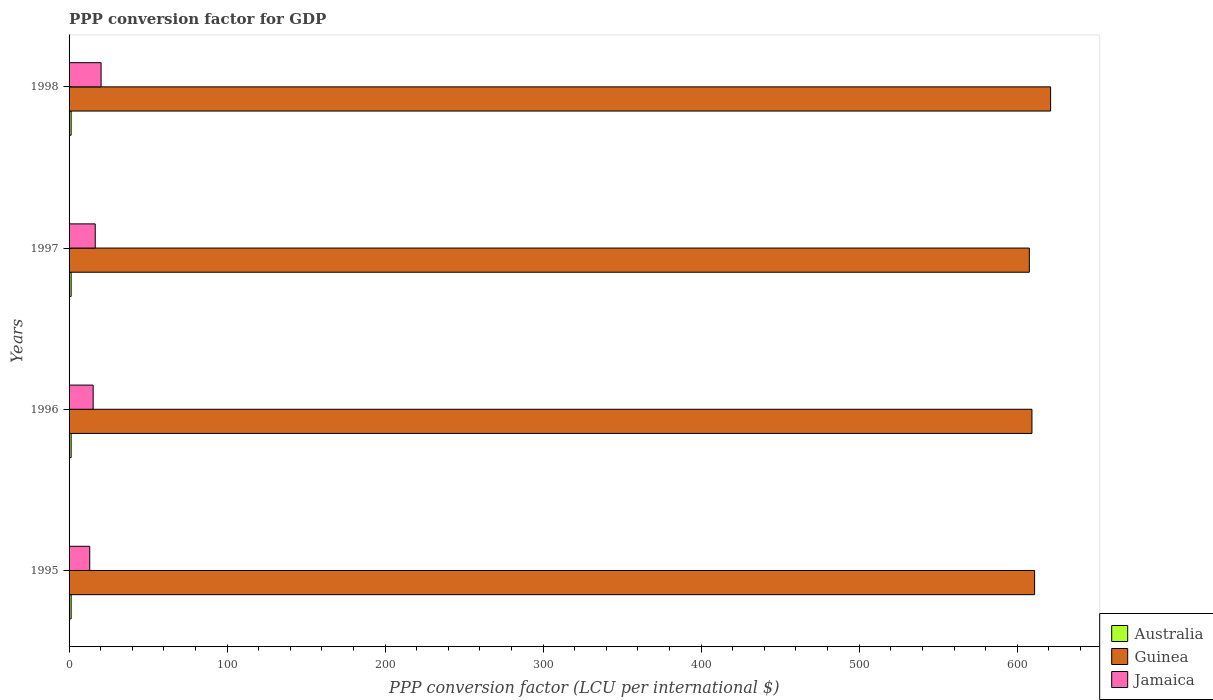How many groups of bars are there?
Provide a short and direct response. 4. Are the number of bars per tick equal to the number of legend labels?
Your answer should be compact. Yes. Are the number of bars on each tick of the Y-axis equal?
Provide a short and direct response. Yes. How many bars are there on the 1st tick from the top?
Provide a short and direct response. 3. How many bars are there on the 3rd tick from the bottom?
Your response must be concise. 3. What is the label of the 4th group of bars from the top?
Your answer should be compact. 1995. In how many cases, is the number of bars for a given year not equal to the number of legend labels?
Your response must be concise. 0. What is the PPP conversion factor for GDP in Guinea in 1997?
Your response must be concise. 607.68. Across all years, what is the maximum PPP conversion factor for GDP in Guinea?
Your answer should be compact. 621.14. Across all years, what is the minimum PPP conversion factor for GDP in Guinea?
Keep it short and to the point. 607.68. What is the total PPP conversion factor for GDP in Jamaica in the graph?
Provide a succinct answer. 65.15. What is the difference between the PPP conversion factor for GDP in Guinea in 1995 and that in 1997?
Your answer should be compact. 3.34. What is the difference between the PPP conversion factor for GDP in Australia in 1996 and the PPP conversion factor for GDP in Jamaica in 1995?
Offer a terse response. -11.77. What is the average PPP conversion factor for GDP in Jamaica per year?
Keep it short and to the point. 16.29. In the year 1998, what is the difference between the PPP conversion factor for GDP in Guinea and PPP conversion factor for GDP in Australia?
Keep it short and to the point. 619.84. What is the ratio of the PPP conversion factor for GDP in Australia in 1995 to that in 1996?
Provide a succinct answer. 1. Is the PPP conversion factor for GDP in Jamaica in 1995 less than that in 1997?
Make the answer very short. Yes. Is the difference between the PPP conversion factor for GDP in Guinea in 1995 and 1996 greater than the difference between the PPP conversion factor for GDP in Australia in 1995 and 1996?
Make the answer very short. Yes. What is the difference between the highest and the second highest PPP conversion factor for GDP in Australia?
Make the answer very short. 0. What is the difference between the highest and the lowest PPP conversion factor for GDP in Australia?
Offer a terse response. 0.01. What does the 1st bar from the top in 1995 represents?
Provide a succinct answer. Jamaica. What does the 2nd bar from the bottom in 1996 represents?
Provide a succinct answer. Guinea. Is it the case that in every year, the sum of the PPP conversion factor for GDP in Guinea and PPP conversion factor for GDP in Australia is greater than the PPP conversion factor for GDP in Jamaica?
Your answer should be very brief. Yes. How many bars are there?
Give a very brief answer. 12. How many years are there in the graph?
Keep it short and to the point. 4. What is the difference between two consecutive major ticks on the X-axis?
Provide a succinct answer. 100. Are the values on the major ticks of X-axis written in scientific E-notation?
Offer a very short reply. No. Where does the legend appear in the graph?
Keep it short and to the point. Bottom right. How are the legend labels stacked?
Your response must be concise. Vertical. What is the title of the graph?
Ensure brevity in your answer.  PPP conversion factor for GDP. What is the label or title of the X-axis?
Offer a very short reply. PPP conversion factor (LCU per international $). What is the label or title of the Y-axis?
Offer a very short reply. Years. What is the PPP conversion factor (LCU per international $) in Australia in 1995?
Your answer should be compact. 1.31. What is the PPP conversion factor (LCU per international $) of Guinea in 1995?
Ensure brevity in your answer.  611.01. What is the PPP conversion factor (LCU per international $) of Jamaica in 1995?
Give a very brief answer. 13.08. What is the PPP conversion factor (LCU per international $) in Australia in 1996?
Keep it short and to the point. 1.31. What is the PPP conversion factor (LCU per international $) of Guinea in 1996?
Your answer should be compact. 609.34. What is the PPP conversion factor (LCU per international $) in Jamaica in 1996?
Keep it short and to the point. 15.25. What is the PPP conversion factor (LCU per international $) in Australia in 1997?
Keep it short and to the point. 1.31. What is the PPP conversion factor (LCU per international $) in Guinea in 1997?
Provide a short and direct response. 607.68. What is the PPP conversion factor (LCU per international $) of Jamaica in 1997?
Give a very brief answer. 16.56. What is the PPP conversion factor (LCU per international $) of Australia in 1998?
Provide a short and direct response. 1.3. What is the PPP conversion factor (LCU per international $) of Guinea in 1998?
Provide a short and direct response. 621.14. What is the PPP conversion factor (LCU per international $) of Jamaica in 1998?
Ensure brevity in your answer.  20.26. Across all years, what is the maximum PPP conversion factor (LCU per international $) of Australia?
Offer a very short reply. 1.31. Across all years, what is the maximum PPP conversion factor (LCU per international $) of Guinea?
Make the answer very short. 621.14. Across all years, what is the maximum PPP conversion factor (LCU per international $) of Jamaica?
Provide a short and direct response. 20.26. Across all years, what is the minimum PPP conversion factor (LCU per international $) in Australia?
Keep it short and to the point. 1.3. Across all years, what is the minimum PPP conversion factor (LCU per international $) of Guinea?
Ensure brevity in your answer.  607.68. Across all years, what is the minimum PPP conversion factor (LCU per international $) of Jamaica?
Provide a short and direct response. 13.08. What is the total PPP conversion factor (LCU per international $) in Australia in the graph?
Make the answer very short. 5.23. What is the total PPP conversion factor (LCU per international $) of Guinea in the graph?
Offer a terse response. 2449.16. What is the total PPP conversion factor (LCU per international $) of Jamaica in the graph?
Offer a very short reply. 65.15. What is the difference between the PPP conversion factor (LCU per international $) in Australia in 1995 and that in 1996?
Provide a short and direct response. -0. What is the difference between the PPP conversion factor (LCU per international $) of Guinea in 1995 and that in 1996?
Your answer should be very brief. 1.68. What is the difference between the PPP conversion factor (LCU per international $) in Jamaica in 1995 and that in 1996?
Your answer should be very brief. -2.17. What is the difference between the PPP conversion factor (LCU per international $) in Australia in 1995 and that in 1997?
Offer a terse response. -0. What is the difference between the PPP conversion factor (LCU per international $) in Guinea in 1995 and that in 1997?
Keep it short and to the point. 3.34. What is the difference between the PPP conversion factor (LCU per international $) of Jamaica in 1995 and that in 1997?
Keep it short and to the point. -3.48. What is the difference between the PPP conversion factor (LCU per international $) in Australia in 1995 and that in 1998?
Offer a very short reply. 0.01. What is the difference between the PPP conversion factor (LCU per international $) in Guinea in 1995 and that in 1998?
Your answer should be compact. -10.12. What is the difference between the PPP conversion factor (LCU per international $) in Jamaica in 1995 and that in 1998?
Give a very brief answer. -7.18. What is the difference between the PPP conversion factor (LCU per international $) of Australia in 1996 and that in 1997?
Your answer should be compact. 0. What is the difference between the PPP conversion factor (LCU per international $) of Guinea in 1996 and that in 1997?
Keep it short and to the point. 1.66. What is the difference between the PPP conversion factor (LCU per international $) in Jamaica in 1996 and that in 1997?
Provide a succinct answer. -1.31. What is the difference between the PPP conversion factor (LCU per international $) of Australia in 1996 and that in 1998?
Provide a succinct answer. 0.01. What is the difference between the PPP conversion factor (LCU per international $) of Guinea in 1996 and that in 1998?
Your answer should be very brief. -11.8. What is the difference between the PPP conversion factor (LCU per international $) in Jamaica in 1996 and that in 1998?
Your response must be concise. -5.01. What is the difference between the PPP conversion factor (LCU per international $) of Australia in 1997 and that in 1998?
Keep it short and to the point. 0.01. What is the difference between the PPP conversion factor (LCU per international $) of Guinea in 1997 and that in 1998?
Your answer should be compact. -13.46. What is the difference between the PPP conversion factor (LCU per international $) in Jamaica in 1997 and that in 1998?
Offer a very short reply. -3.7. What is the difference between the PPP conversion factor (LCU per international $) of Australia in 1995 and the PPP conversion factor (LCU per international $) of Guinea in 1996?
Offer a very short reply. -608.03. What is the difference between the PPP conversion factor (LCU per international $) of Australia in 1995 and the PPP conversion factor (LCU per international $) of Jamaica in 1996?
Offer a terse response. -13.94. What is the difference between the PPP conversion factor (LCU per international $) of Guinea in 1995 and the PPP conversion factor (LCU per international $) of Jamaica in 1996?
Offer a very short reply. 595.76. What is the difference between the PPP conversion factor (LCU per international $) in Australia in 1995 and the PPP conversion factor (LCU per international $) in Guinea in 1997?
Ensure brevity in your answer.  -606.37. What is the difference between the PPP conversion factor (LCU per international $) of Australia in 1995 and the PPP conversion factor (LCU per international $) of Jamaica in 1997?
Offer a terse response. -15.25. What is the difference between the PPP conversion factor (LCU per international $) in Guinea in 1995 and the PPP conversion factor (LCU per international $) in Jamaica in 1997?
Offer a terse response. 594.45. What is the difference between the PPP conversion factor (LCU per international $) in Australia in 1995 and the PPP conversion factor (LCU per international $) in Guinea in 1998?
Keep it short and to the point. -619.83. What is the difference between the PPP conversion factor (LCU per international $) in Australia in 1995 and the PPP conversion factor (LCU per international $) in Jamaica in 1998?
Ensure brevity in your answer.  -18.95. What is the difference between the PPP conversion factor (LCU per international $) in Guinea in 1995 and the PPP conversion factor (LCU per international $) in Jamaica in 1998?
Provide a succinct answer. 590.76. What is the difference between the PPP conversion factor (LCU per international $) of Australia in 1996 and the PPP conversion factor (LCU per international $) of Guinea in 1997?
Your answer should be compact. -606.36. What is the difference between the PPP conversion factor (LCU per international $) in Australia in 1996 and the PPP conversion factor (LCU per international $) in Jamaica in 1997?
Your answer should be very brief. -15.25. What is the difference between the PPP conversion factor (LCU per international $) in Guinea in 1996 and the PPP conversion factor (LCU per international $) in Jamaica in 1997?
Offer a terse response. 592.78. What is the difference between the PPP conversion factor (LCU per international $) in Australia in 1996 and the PPP conversion factor (LCU per international $) in Guinea in 1998?
Provide a short and direct response. -619.83. What is the difference between the PPP conversion factor (LCU per international $) of Australia in 1996 and the PPP conversion factor (LCU per international $) of Jamaica in 1998?
Offer a terse response. -18.95. What is the difference between the PPP conversion factor (LCU per international $) in Guinea in 1996 and the PPP conversion factor (LCU per international $) in Jamaica in 1998?
Provide a succinct answer. 589.08. What is the difference between the PPP conversion factor (LCU per international $) in Australia in 1997 and the PPP conversion factor (LCU per international $) in Guinea in 1998?
Provide a short and direct response. -619.83. What is the difference between the PPP conversion factor (LCU per international $) of Australia in 1997 and the PPP conversion factor (LCU per international $) of Jamaica in 1998?
Your response must be concise. -18.95. What is the difference between the PPP conversion factor (LCU per international $) in Guinea in 1997 and the PPP conversion factor (LCU per international $) in Jamaica in 1998?
Keep it short and to the point. 587.42. What is the average PPP conversion factor (LCU per international $) of Australia per year?
Your answer should be compact. 1.31. What is the average PPP conversion factor (LCU per international $) of Guinea per year?
Make the answer very short. 612.29. What is the average PPP conversion factor (LCU per international $) in Jamaica per year?
Provide a short and direct response. 16.29. In the year 1995, what is the difference between the PPP conversion factor (LCU per international $) in Australia and PPP conversion factor (LCU per international $) in Guinea?
Keep it short and to the point. -609.71. In the year 1995, what is the difference between the PPP conversion factor (LCU per international $) of Australia and PPP conversion factor (LCU per international $) of Jamaica?
Your answer should be very brief. -11.77. In the year 1995, what is the difference between the PPP conversion factor (LCU per international $) in Guinea and PPP conversion factor (LCU per international $) in Jamaica?
Your answer should be compact. 597.94. In the year 1996, what is the difference between the PPP conversion factor (LCU per international $) in Australia and PPP conversion factor (LCU per international $) in Guinea?
Provide a short and direct response. -608.02. In the year 1996, what is the difference between the PPP conversion factor (LCU per international $) of Australia and PPP conversion factor (LCU per international $) of Jamaica?
Make the answer very short. -13.94. In the year 1996, what is the difference between the PPP conversion factor (LCU per international $) of Guinea and PPP conversion factor (LCU per international $) of Jamaica?
Give a very brief answer. 594.09. In the year 1997, what is the difference between the PPP conversion factor (LCU per international $) of Australia and PPP conversion factor (LCU per international $) of Guinea?
Your answer should be very brief. -606.36. In the year 1997, what is the difference between the PPP conversion factor (LCU per international $) in Australia and PPP conversion factor (LCU per international $) in Jamaica?
Your response must be concise. -15.25. In the year 1997, what is the difference between the PPP conversion factor (LCU per international $) of Guinea and PPP conversion factor (LCU per international $) of Jamaica?
Offer a terse response. 591.12. In the year 1998, what is the difference between the PPP conversion factor (LCU per international $) of Australia and PPP conversion factor (LCU per international $) of Guinea?
Offer a terse response. -619.84. In the year 1998, what is the difference between the PPP conversion factor (LCU per international $) in Australia and PPP conversion factor (LCU per international $) in Jamaica?
Your response must be concise. -18.96. In the year 1998, what is the difference between the PPP conversion factor (LCU per international $) in Guinea and PPP conversion factor (LCU per international $) in Jamaica?
Offer a very short reply. 600.88. What is the ratio of the PPP conversion factor (LCU per international $) of Australia in 1995 to that in 1996?
Your response must be concise. 1. What is the ratio of the PPP conversion factor (LCU per international $) of Guinea in 1995 to that in 1996?
Your answer should be very brief. 1. What is the ratio of the PPP conversion factor (LCU per international $) of Jamaica in 1995 to that in 1996?
Your response must be concise. 0.86. What is the ratio of the PPP conversion factor (LCU per international $) of Guinea in 1995 to that in 1997?
Give a very brief answer. 1.01. What is the ratio of the PPP conversion factor (LCU per international $) of Jamaica in 1995 to that in 1997?
Give a very brief answer. 0.79. What is the ratio of the PPP conversion factor (LCU per international $) of Guinea in 1995 to that in 1998?
Provide a succinct answer. 0.98. What is the ratio of the PPP conversion factor (LCU per international $) of Jamaica in 1995 to that in 1998?
Provide a short and direct response. 0.65. What is the ratio of the PPP conversion factor (LCU per international $) in Guinea in 1996 to that in 1997?
Provide a succinct answer. 1. What is the ratio of the PPP conversion factor (LCU per international $) of Jamaica in 1996 to that in 1997?
Provide a succinct answer. 0.92. What is the ratio of the PPP conversion factor (LCU per international $) in Jamaica in 1996 to that in 1998?
Keep it short and to the point. 0.75. What is the ratio of the PPP conversion factor (LCU per international $) in Australia in 1997 to that in 1998?
Your answer should be very brief. 1.01. What is the ratio of the PPP conversion factor (LCU per international $) of Guinea in 1997 to that in 1998?
Give a very brief answer. 0.98. What is the ratio of the PPP conversion factor (LCU per international $) of Jamaica in 1997 to that in 1998?
Your response must be concise. 0.82. What is the difference between the highest and the second highest PPP conversion factor (LCU per international $) of Australia?
Make the answer very short. 0. What is the difference between the highest and the second highest PPP conversion factor (LCU per international $) of Guinea?
Offer a terse response. 10.12. What is the difference between the highest and the second highest PPP conversion factor (LCU per international $) in Jamaica?
Your answer should be compact. 3.7. What is the difference between the highest and the lowest PPP conversion factor (LCU per international $) of Australia?
Provide a short and direct response. 0.01. What is the difference between the highest and the lowest PPP conversion factor (LCU per international $) of Guinea?
Offer a very short reply. 13.46. What is the difference between the highest and the lowest PPP conversion factor (LCU per international $) in Jamaica?
Offer a very short reply. 7.18. 